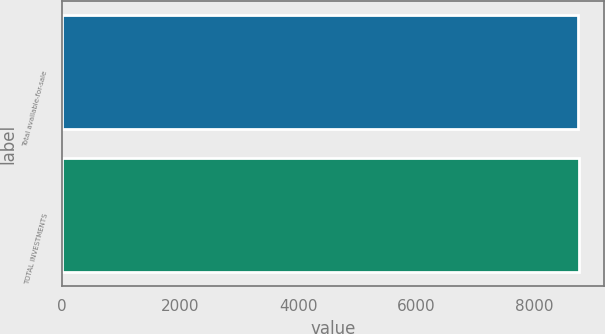Convert chart. <chart><loc_0><loc_0><loc_500><loc_500><bar_chart><fcel>Total available-for-sale<fcel>TOTAL INVESTMENTS<nl><fcel>8741<fcel>8741.1<nl></chart> 